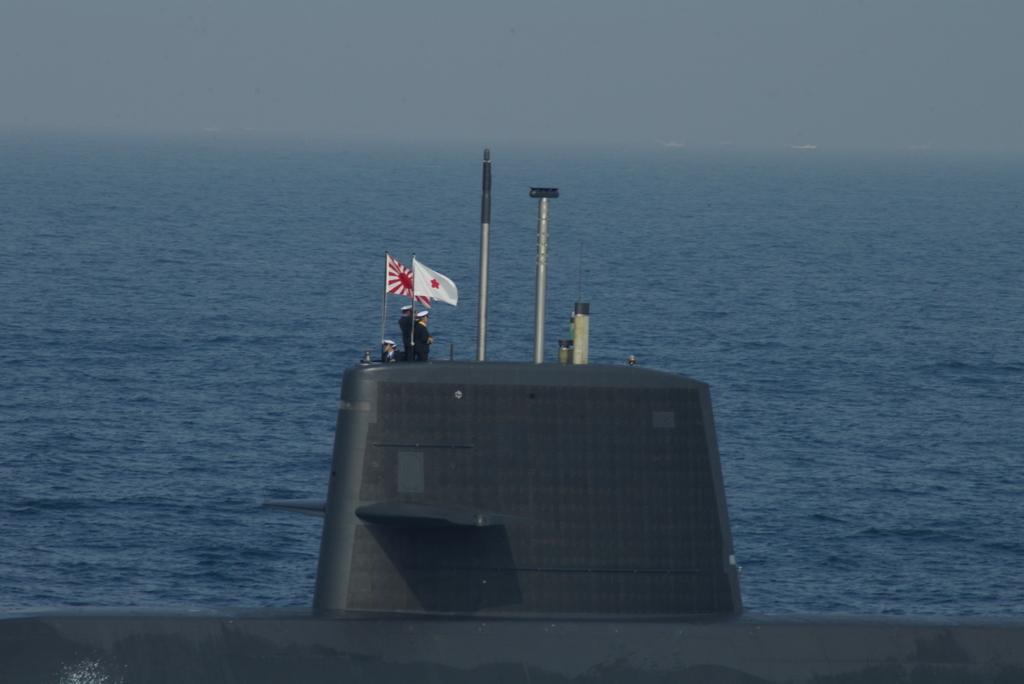What is the main subject of the image? The main subject of the image is a submarine. Are there any people present in the image? Yes, there are people on the submarine. What can be seen flying in the image? Flags are visible in the image. What are the poles used for in the image? The poles are likely used for supporting the flags. What else can be seen in the water in the image? There are boats in the water in the image. What is the tendency of the name of the submarine in the image? There is no name visible for the submarine in the image, so it is not possible to determine any tendency related to its name. 